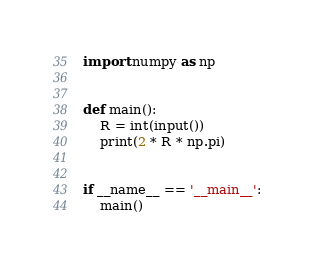<code> <loc_0><loc_0><loc_500><loc_500><_Python_>import numpy as np


def main():
    R = int(input())
    print(2 * R * np.pi)


if __name__ == '__main__':
    main()
</code> 